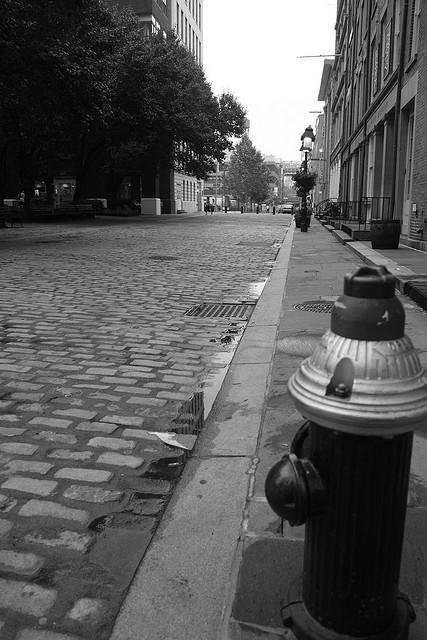Are there any cars parked on the street?
Quick response, please. No. What is in the lower right side?
Answer briefly. Fire hydrant. Is the street paved in black top?
Give a very brief answer. No. What else is lined along the bricked curb?
Answer briefly. Fire hydrant. 